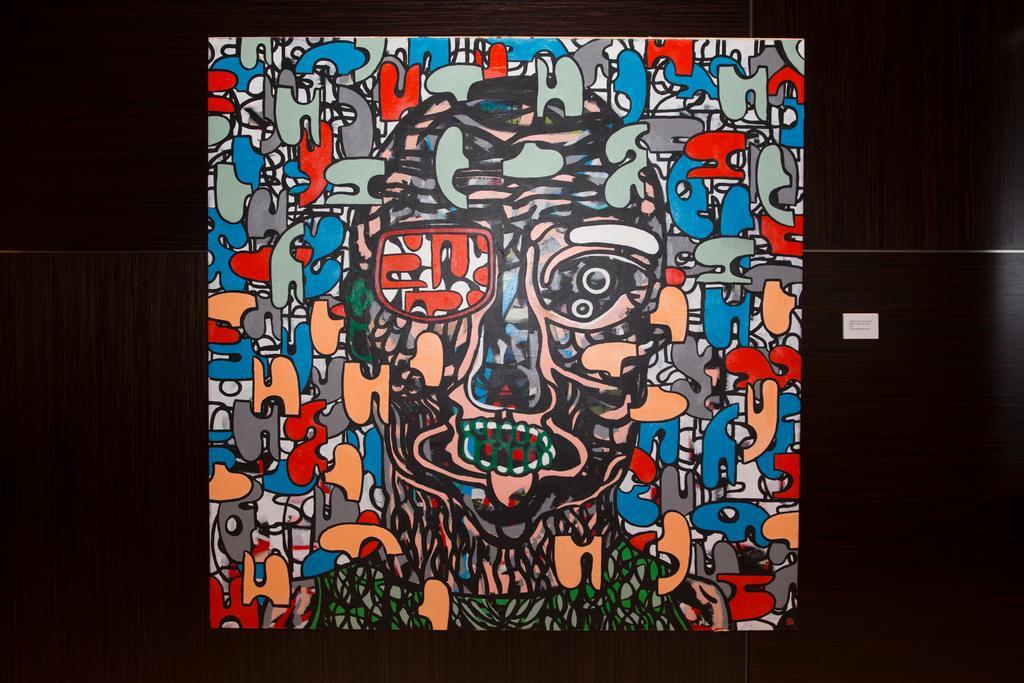Describe this image in one or two sentences. In the center of the image we can see the cartoon pictures are present on a board. On the right side of the image we can see a board which contains text. In the background of the image we can see the wall. 